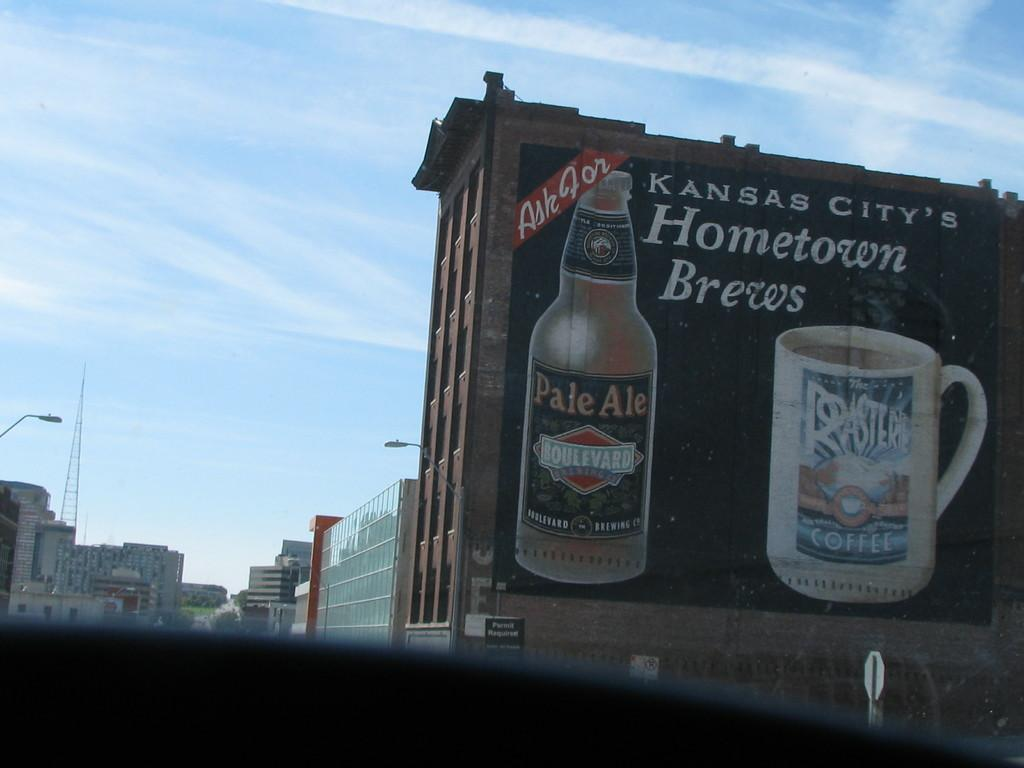<image>
Write a terse but informative summary of the picture. On the side of a building is an advertisement for Boulevard Pale Ale and Roasters Coffee. 